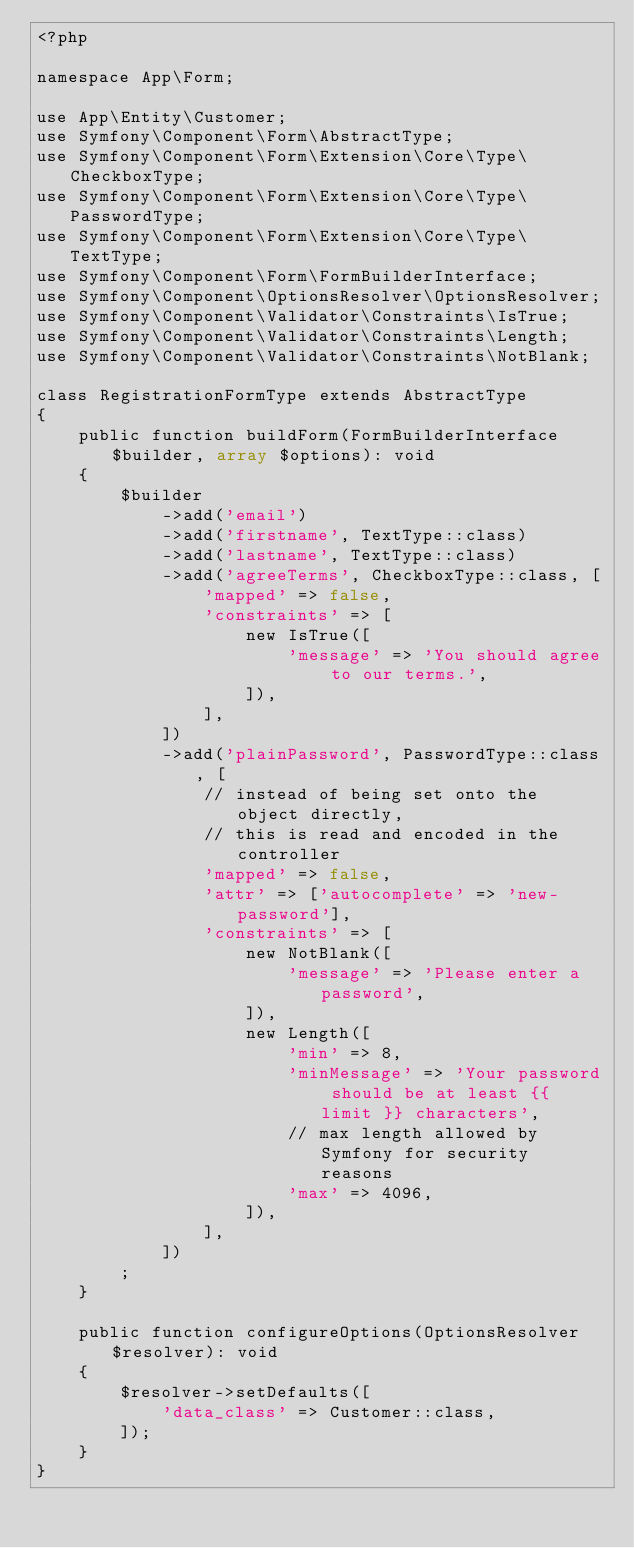<code> <loc_0><loc_0><loc_500><loc_500><_PHP_><?php

namespace App\Form;

use App\Entity\Customer;
use Symfony\Component\Form\AbstractType;
use Symfony\Component\Form\Extension\Core\Type\CheckboxType;
use Symfony\Component\Form\Extension\Core\Type\PasswordType;
use Symfony\Component\Form\Extension\Core\Type\TextType;
use Symfony\Component\Form\FormBuilderInterface;
use Symfony\Component\OptionsResolver\OptionsResolver;
use Symfony\Component\Validator\Constraints\IsTrue;
use Symfony\Component\Validator\Constraints\Length;
use Symfony\Component\Validator\Constraints\NotBlank;

class RegistrationFormType extends AbstractType
{
    public function buildForm(FormBuilderInterface $builder, array $options): void
    {
        $builder
            ->add('email')
            ->add('firstname', TextType::class)
            ->add('lastname', TextType::class)
            ->add('agreeTerms', CheckboxType::class, [
                'mapped' => false,
                'constraints' => [
                    new IsTrue([
                        'message' => 'You should agree to our terms.',
                    ]),
                ],
            ])
            ->add('plainPassword', PasswordType::class, [
                // instead of being set onto the object directly,
                // this is read and encoded in the controller
                'mapped' => false,
                'attr' => ['autocomplete' => 'new-password'],
                'constraints' => [
                    new NotBlank([
                        'message' => 'Please enter a password',
                    ]),
                    new Length([
                        'min' => 8,
                        'minMessage' => 'Your password should be at least {{ limit }} characters',
                        // max length allowed by Symfony for security reasons
                        'max' => 4096,
                    ]),
                ],
            ])
        ;
    }

    public function configureOptions(OptionsResolver $resolver): void
    {
        $resolver->setDefaults([
            'data_class' => Customer::class,
        ]);
    }
}
</code> 